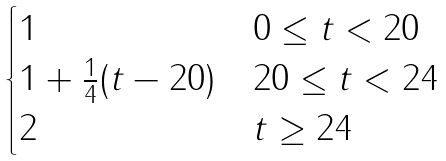Convert formula to latex. <formula><loc_0><loc_0><loc_500><loc_500>\begin{cases} 1 & 0 \leq t < 2 0 \\ 1 + \frac { 1 } { 4 } ( t - 2 0 ) & 2 0 \leq t < 2 4 \\ 2 & t \geq 2 4 \end{cases}</formula> 